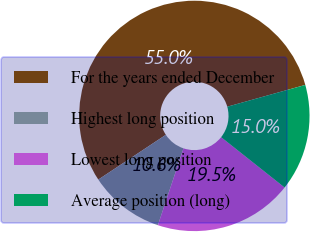Convert chart to OTSL. <chart><loc_0><loc_0><loc_500><loc_500><pie_chart><fcel>For the years ended December<fcel>Highest long position<fcel>Lowest long position<fcel>Average position (long)<nl><fcel>54.98%<fcel>10.56%<fcel>19.45%<fcel>15.01%<nl></chart> 